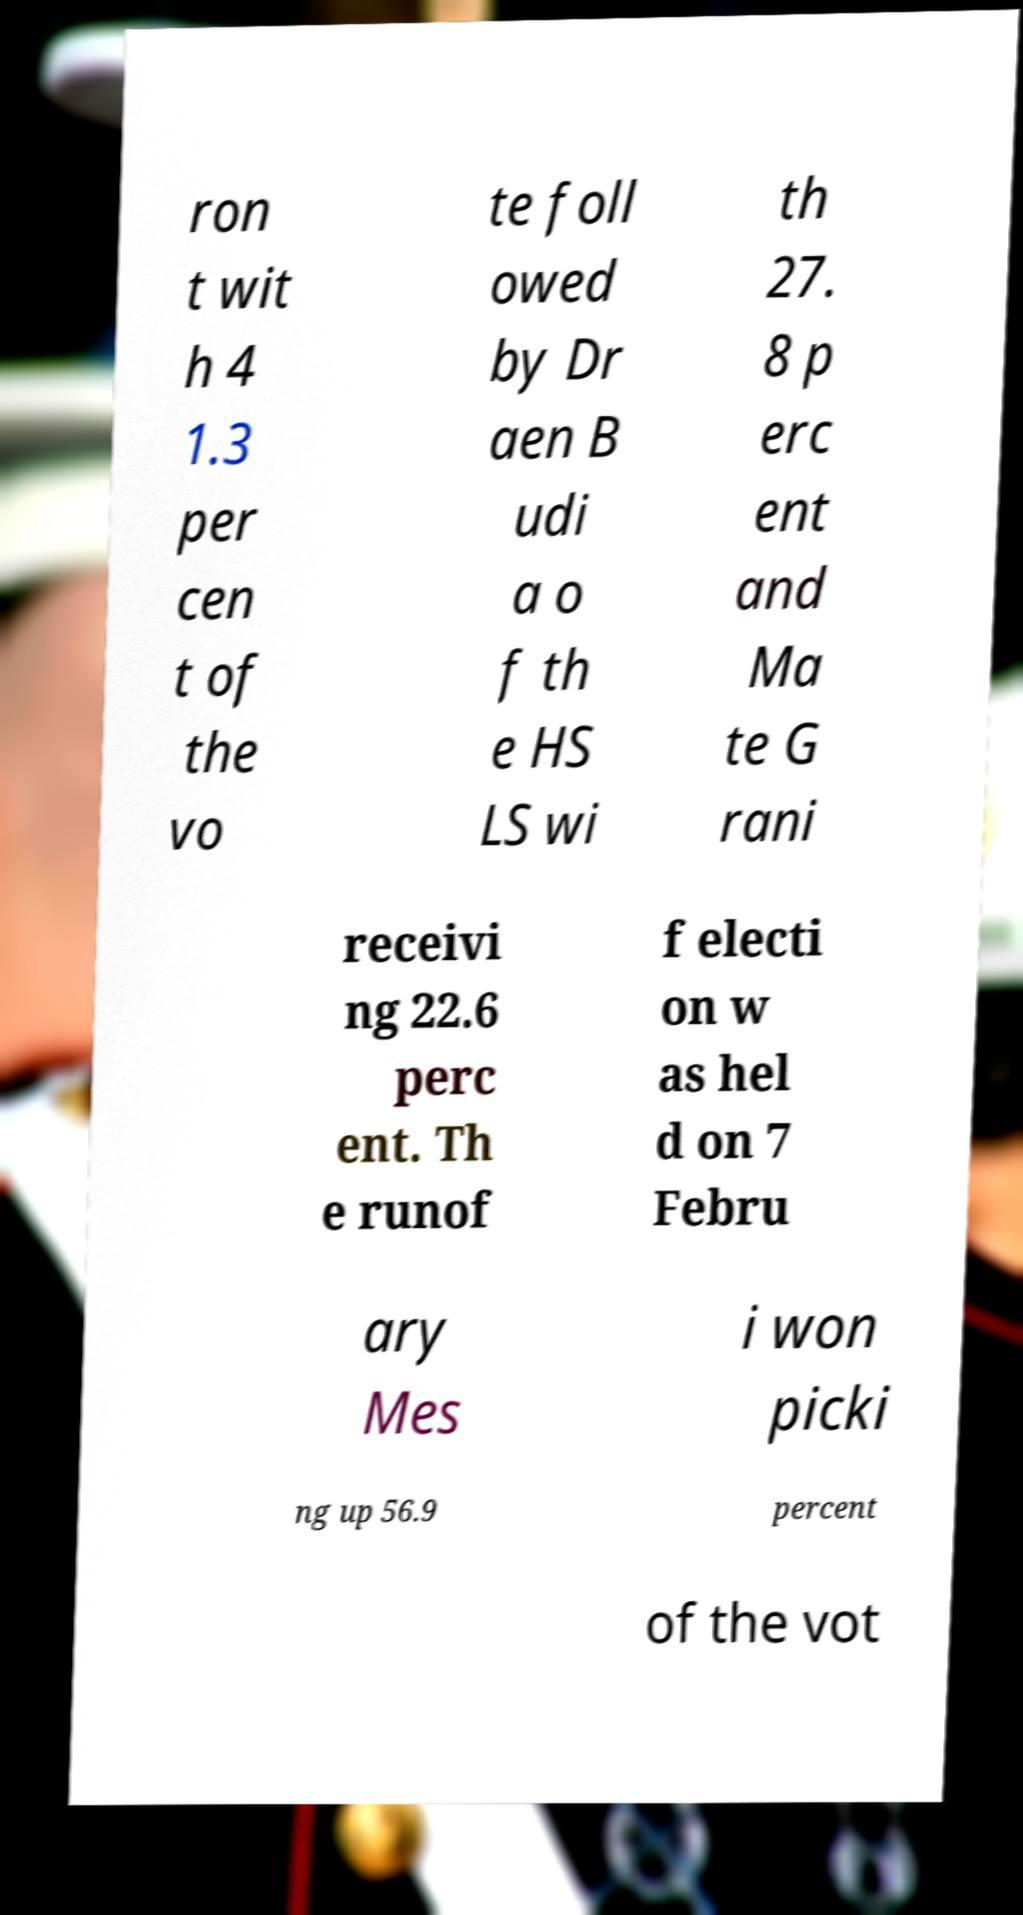For documentation purposes, I need the text within this image transcribed. Could you provide that? ron t wit h 4 1.3 per cen t of the vo te foll owed by Dr aen B udi a o f th e HS LS wi th 27. 8 p erc ent and Ma te G rani receivi ng 22.6 perc ent. Th e runof f electi on w as hel d on 7 Febru ary Mes i won picki ng up 56.9 percent of the vot 